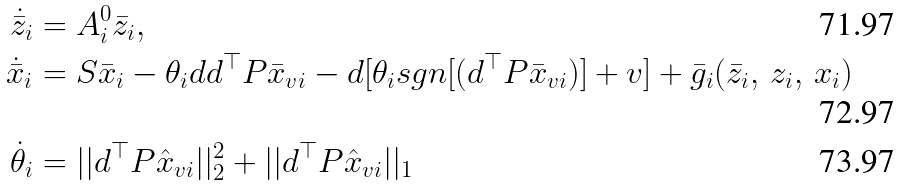<formula> <loc_0><loc_0><loc_500><loc_500>\dot { \bar { z } } _ { i } & = A _ { i } ^ { 0 } \bar { z } _ { i } , \\ \dot { \bar { x } } _ { i } & = S \bar { x } _ { i } - \theta _ { i } d d ^ { \top } P \bar { x } _ { v i } - d [ \theta _ { i } s g n [ ( d ^ { \top } P \bar { x } _ { v i } ) ] + v ] + \bar { g } _ { i } ( \bar { z } _ { i } , \, z _ { i } , \, x _ { i } ) \\ \dot { \theta } _ { i } & = | | d ^ { \top } P \hat { x } _ { v i } | | _ { 2 } ^ { 2 } + | | d ^ { \top } P \hat { x } _ { v i } | | _ { 1 }</formula> 